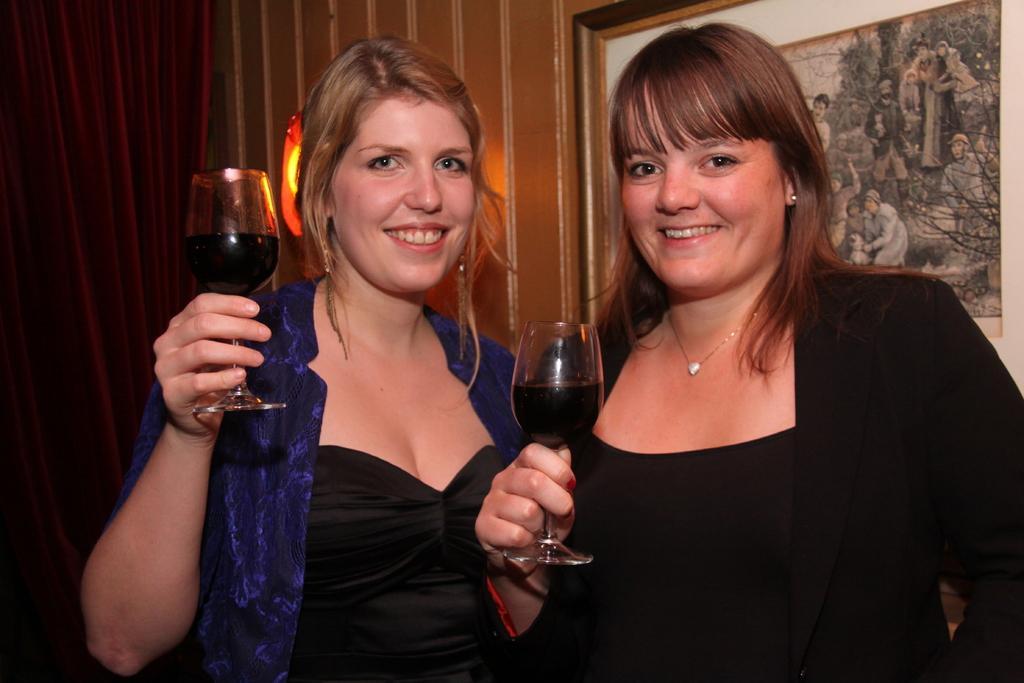Could you give a brief overview of what you see in this image? This image consist of two women. To the right, the woman is wearing black dress and to the left, the woman is wearing blue shirt. Both are holding glasses in their hands. In the background, there is a wall on which frames are fixed. 